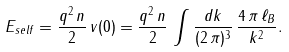Convert formula to latex. <formula><loc_0><loc_0><loc_500><loc_500>E _ { s e l f } = \frac { q ^ { 2 } \, n } { 2 } \, v ( 0 ) = \frac { q ^ { 2 } \, n } { 2 } \, \int \frac { { d } k } { ( 2 \, \pi ) ^ { 3 } } \, \frac { 4 \, \pi \, \ell _ { B } } { k ^ { 2 } } .</formula> 